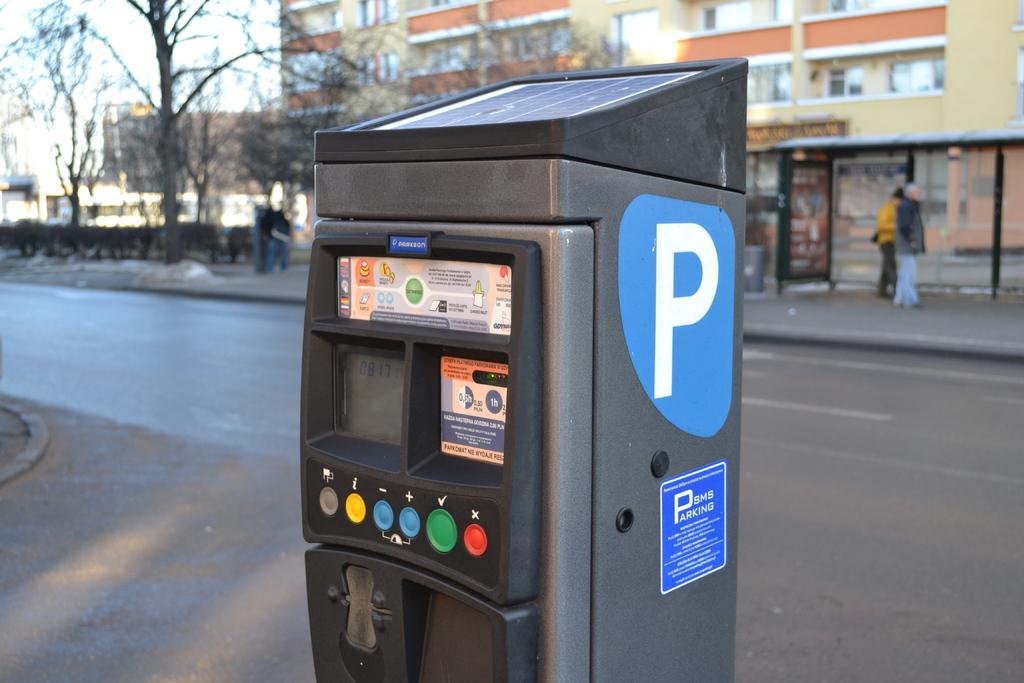What kind of parking is this kiosk for?
Give a very brief answer. Sms. 